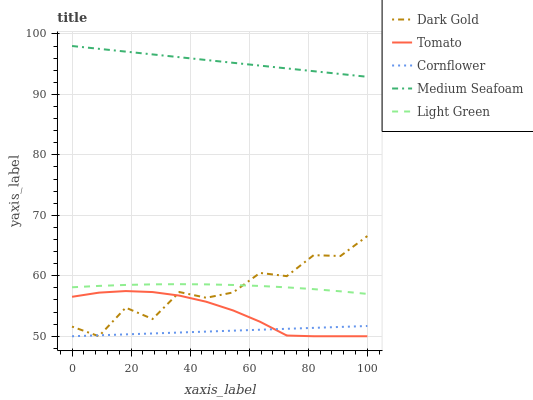Does Cornflower have the minimum area under the curve?
Answer yes or no. Yes. Does Medium Seafoam have the maximum area under the curve?
Answer yes or no. Yes. Does Medium Seafoam have the minimum area under the curve?
Answer yes or no. No. Does Cornflower have the maximum area under the curve?
Answer yes or no. No. Is Cornflower the smoothest?
Answer yes or no. Yes. Is Dark Gold the roughest?
Answer yes or no. Yes. Is Medium Seafoam the smoothest?
Answer yes or no. No. Is Medium Seafoam the roughest?
Answer yes or no. No. Does Tomato have the lowest value?
Answer yes or no. Yes. Does Medium Seafoam have the lowest value?
Answer yes or no. No. Does Medium Seafoam have the highest value?
Answer yes or no. Yes. Does Cornflower have the highest value?
Answer yes or no. No. Is Dark Gold less than Medium Seafoam?
Answer yes or no. Yes. Is Light Green greater than Cornflower?
Answer yes or no. Yes. Does Dark Gold intersect Tomato?
Answer yes or no. Yes. Is Dark Gold less than Tomato?
Answer yes or no. No. Is Dark Gold greater than Tomato?
Answer yes or no. No. Does Dark Gold intersect Medium Seafoam?
Answer yes or no. No. 